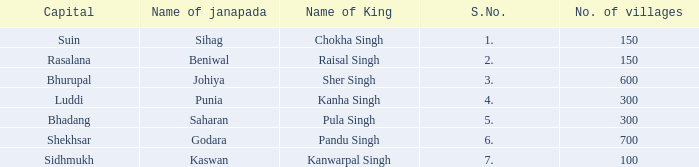Could you help me parse every detail presented in this table? {'header': ['Capital', 'Name of janapada', 'Name of King', 'S.No.', 'No. of villages'], 'rows': [['Suin', 'Sihag', 'Chokha Singh', '1.', '150'], ['Rasalana', 'Beniwal', 'Raisal Singh', '2.', '150'], ['Bhurupal', 'Johiya', 'Sher Singh', '3.', '600'], ['Luddi', 'Punia', 'Kanha Singh', '4.', '300'], ['Bhadang', 'Saharan', 'Pula Singh', '5.', '300'], ['Shekhsar', 'Godara', 'Pandu Singh', '6.', '700'], ['Sidhmukh', 'Kaswan', 'Kanwarpal Singh', '7.', '100']]} What king has an S. number over 1 and a number of villages of 600? Sher Singh. 